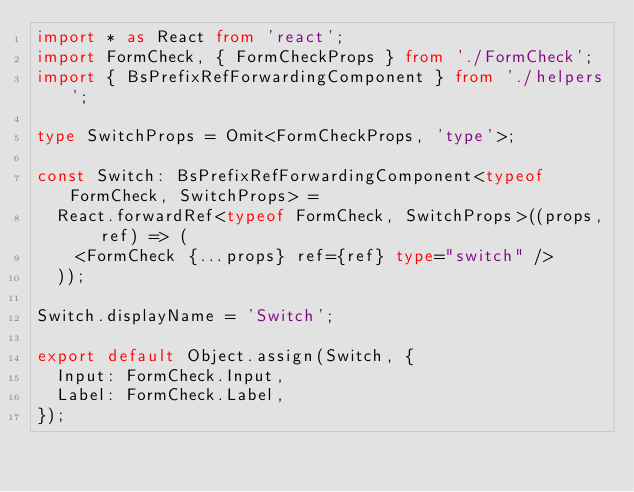<code> <loc_0><loc_0><loc_500><loc_500><_TypeScript_>import * as React from 'react';
import FormCheck, { FormCheckProps } from './FormCheck';
import { BsPrefixRefForwardingComponent } from './helpers';

type SwitchProps = Omit<FormCheckProps, 'type'>;

const Switch: BsPrefixRefForwardingComponent<typeof FormCheck, SwitchProps> =
  React.forwardRef<typeof FormCheck, SwitchProps>((props, ref) => (
    <FormCheck {...props} ref={ref} type="switch" />
  ));

Switch.displayName = 'Switch';

export default Object.assign(Switch, {
  Input: FormCheck.Input,
  Label: FormCheck.Label,
});
</code> 